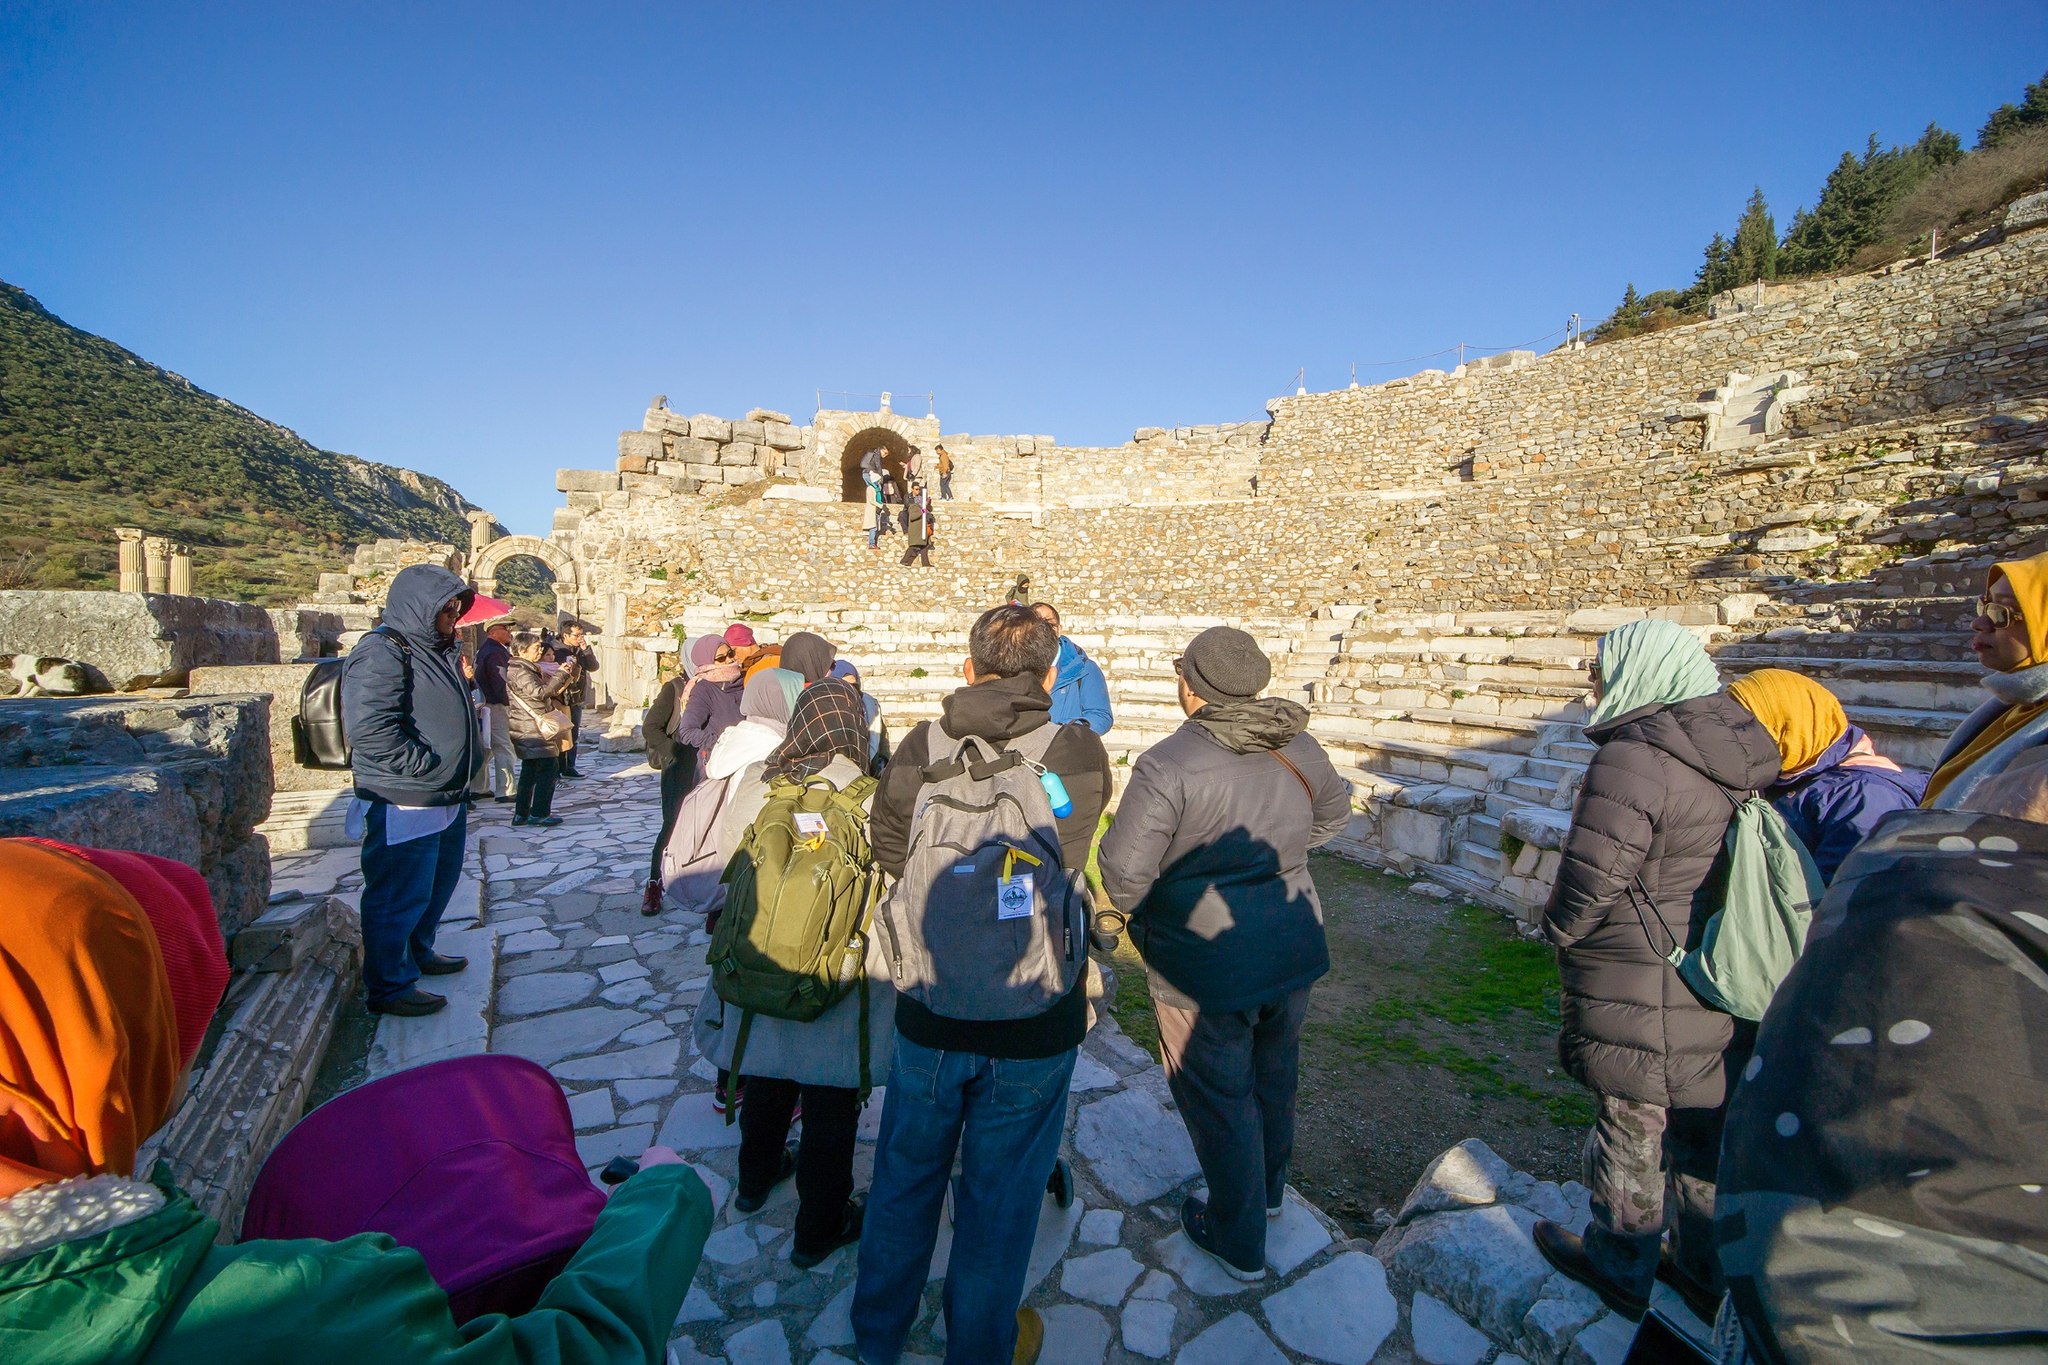If you could add one fantastical element to this scene, what would it be and why? If I could add one fantastical element to this scene, it would be the presence of spectral figures from the past, wandering amongst the tourists. These ethereal beings would be dressed in the traditional garb of the ancient civilization that once inhabited the ruins. They would interact with the site as they did in their time, offering a mesmerizing blend of history and mysticism. Their presence would serve as a living history lesson, allowing the tourists to see firsthand the daily life, ceremonies, and routines that once brought vibrancy to these now silent stones. This supernatural addition would create a dynamic and engaging bridge between the past and present, enhancing the educational experience in a truly unforgettable way.  Describe this place from the perspective of an archaeologist. From an archaeologist's perspective, this site is a treasure trove of historical data and cultural heritage. The weathered stone pathways and the remaining archway signify an architectural marvel from the past, hinting at the construction techniques and materials used by ancient builders. The amphitheater-like setting suggests a communal area for public gatherings, performances, or civic discussions. Each stone and artifact here speaks volumes, offering clues about the socioeconomic structure, daily life, artistic expressions, and technological advancements of the civilization that once thrived here. The surrounding nature, with its trees and mountainous backdrop, provides context to the geographical and environmental factors that influenced the site’s development. For an archaeologist, this is not just a ruin, but a living narrative waiting to be pieced together, analyzed, and shared with the world. 